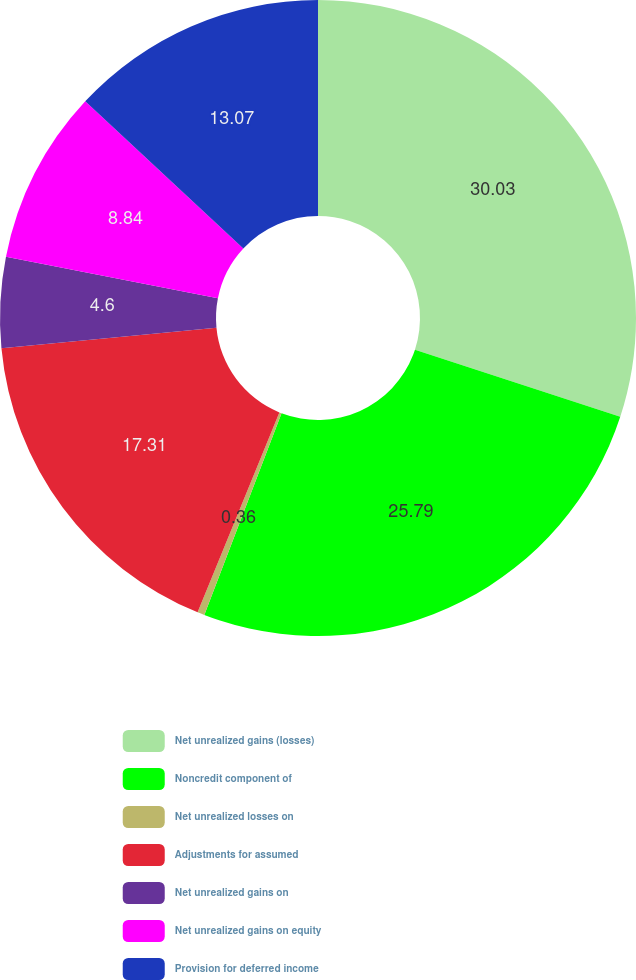Convert chart to OTSL. <chart><loc_0><loc_0><loc_500><loc_500><pie_chart><fcel>Net unrealized gains (losses)<fcel>Noncredit component of<fcel>Net unrealized losses on<fcel>Adjustments for assumed<fcel>Net unrealized gains on<fcel>Net unrealized gains on equity<fcel>Provision for deferred income<nl><fcel>30.03%<fcel>25.79%<fcel>0.36%<fcel>17.31%<fcel>4.6%<fcel>8.84%<fcel>13.07%<nl></chart> 